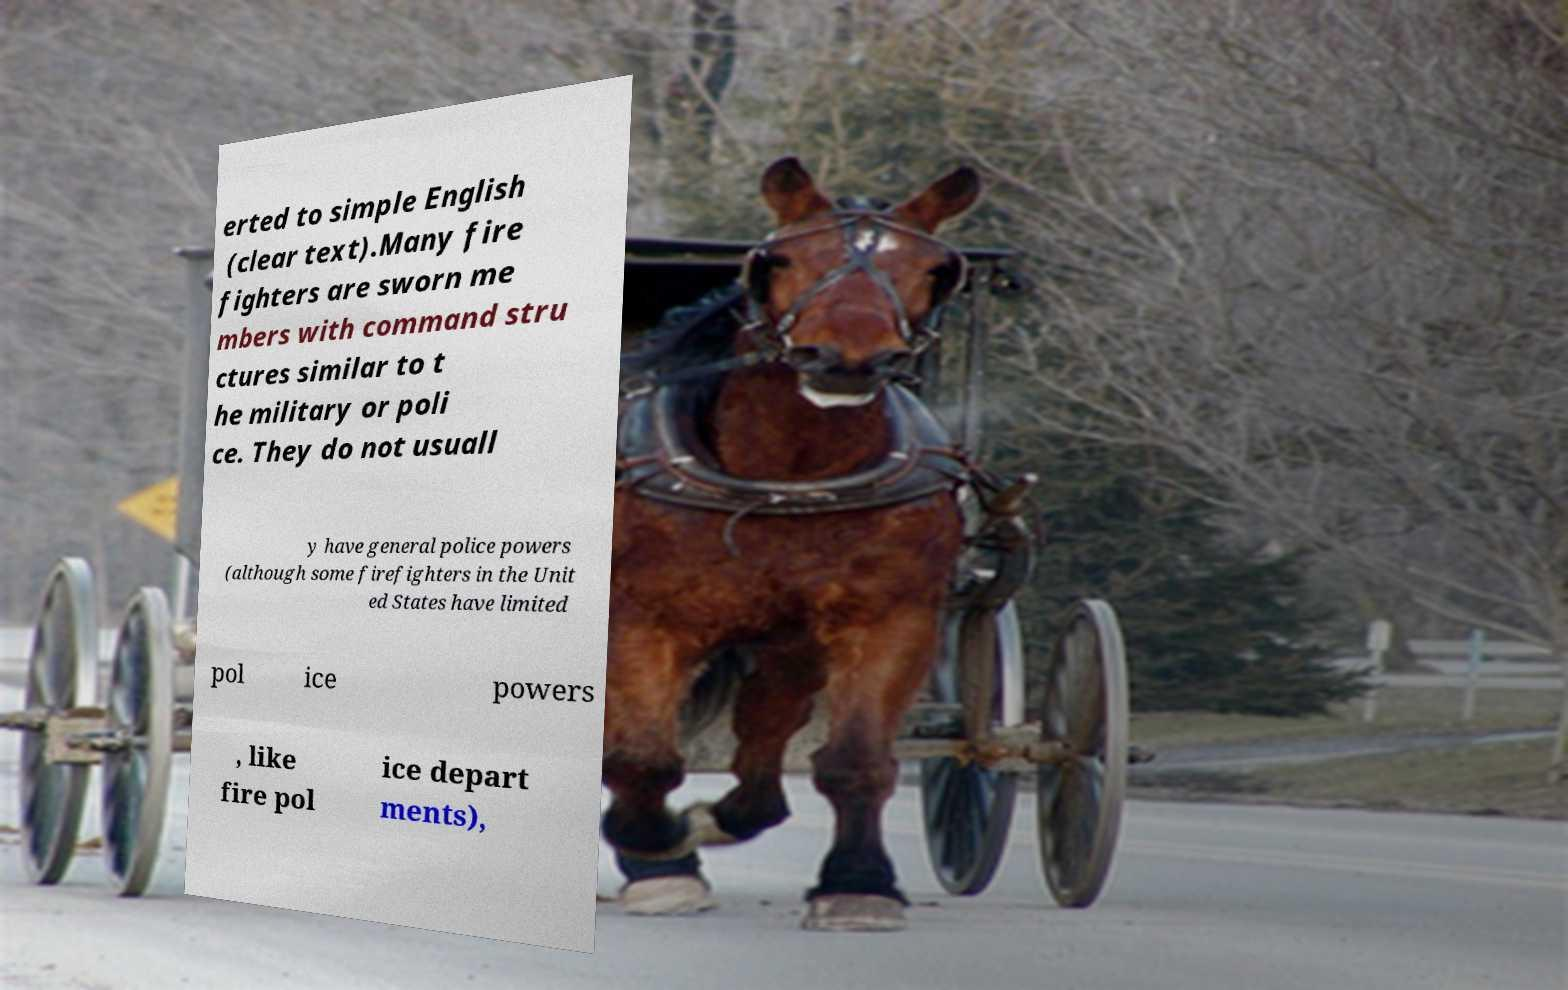Could you extract and type out the text from this image? erted to simple English (clear text).Many fire fighters are sworn me mbers with command stru ctures similar to t he military or poli ce. They do not usuall y have general police powers (although some firefighters in the Unit ed States have limited pol ice powers , like fire pol ice depart ments), 